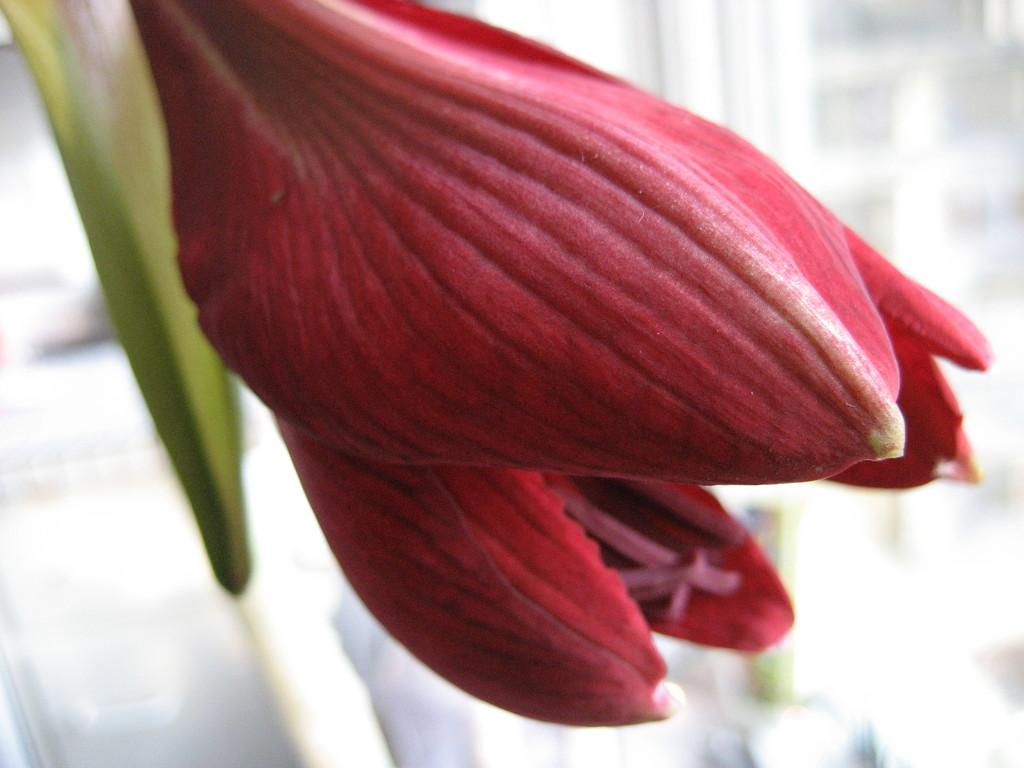What is present in the image? There is a flower in the image. Can you describe any specific features of the flower? The flower has a leaf. What type of music is being played by the flower in the image? There is no music or indication of music being played in the image; it features a flower with a leaf. How many beads are visible on the flower in the image? There are no beads present on the flower in the image. 